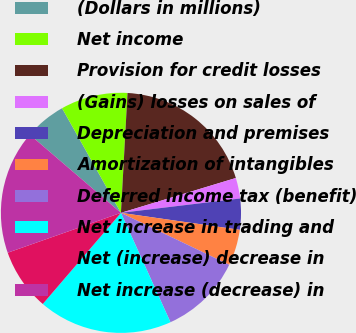Convert chart. <chart><loc_0><loc_0><loc_500><loc_500><pie_chart><fcel>(Dollars in millions)<fcel>Net income<fcel>Provision for credit losses<fcel>(Gains) losses on sales of<fcel>Depreciation and premises<fcel>Amortization of intangibles<fcel>Deferred income tax (benefit)<fcel>Net increase in trading and<fcel>Net (increase) decrease in<fcel>Net increase (decrease) in<nl><fcel>5.56%<fcel>9.03%<fcel>19.44%<fcel>2.78%<fcel>4.17%<fcel>4.86%<fcel>11.11%<fcel>18.05%<fcel>8.33%<fcel>16.67%<nl></chart> 